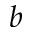Convert formula to latex. <formula><loc_0><loc_0><loc_500><loc_500>b</formula> 